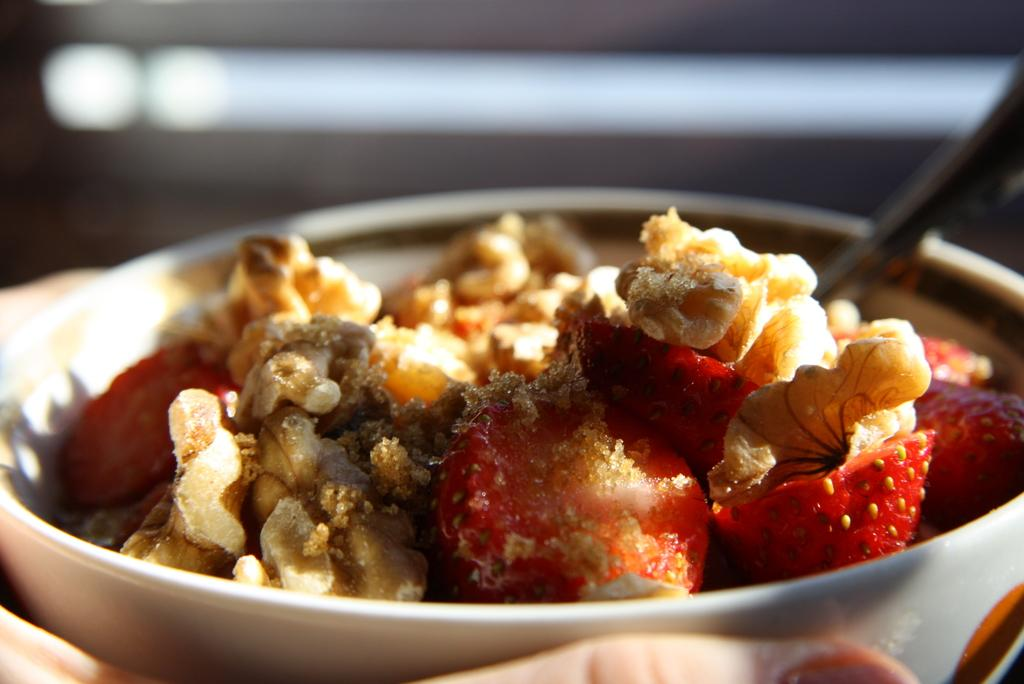What type of container holds the food in the image? There is food in a white bowl in the image. Can you describe the background of the image? The background of the image is blurred. What type of oil is being used to cook the food in the image? There is no indication of oil or cooking in the image; it only shows food in a white bowl. 